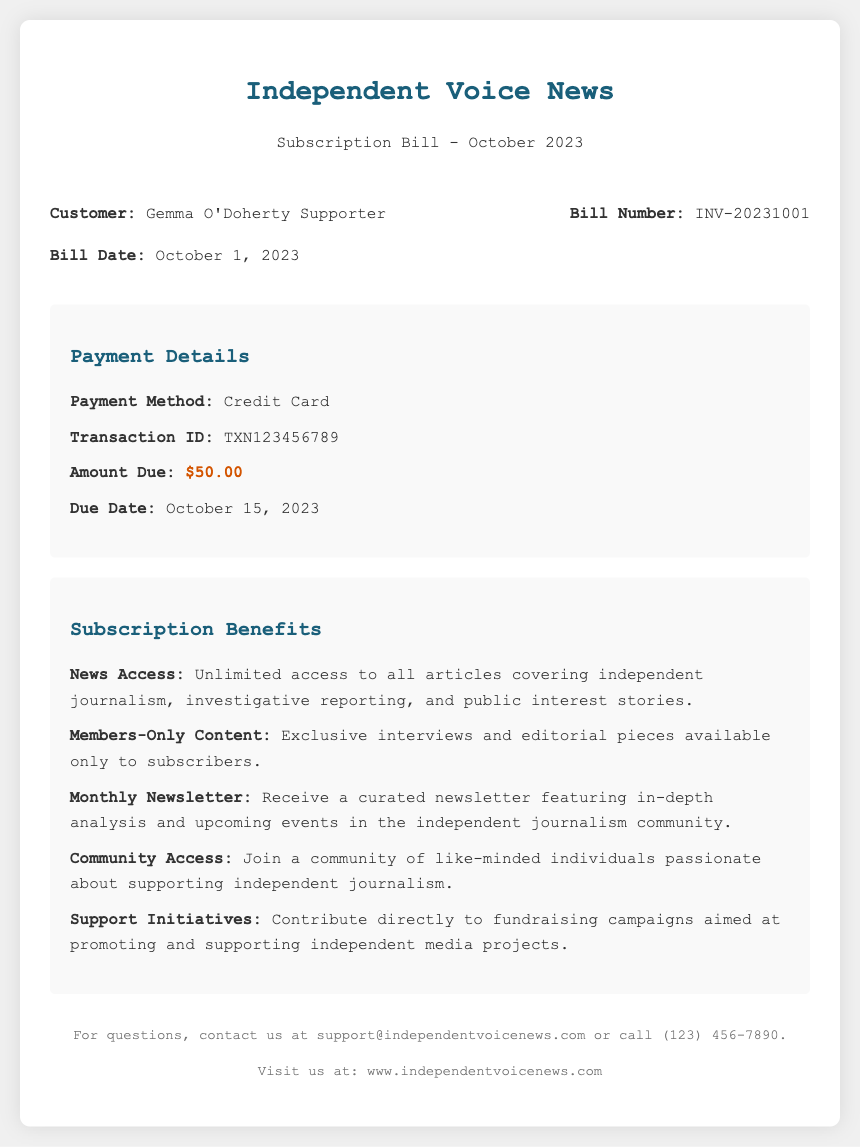What is the subscription amount due? The subscription amount due is explicitly stated in the payment details section.
Answer: $50.00 What is the due date for the payment? The due date for the payment is provided under the payment details.
Answer: October 15, 2023 What is the transaction ID for this payment? The transaction ID is included in the payment details section of the document.
Answer: TXN123456789 What is the bill number? The bill number can be found in the bill information area of the document.
Answer: INV-20231001 What type of payment method is used? The payment method is listed in the payment details section.
Answer: Credit Card What is one benefit of the subscription? Benefits of the subscription are detailed in the subscription benefits section.
Answer: Unlimited access to all articles How often will subscribers receive the newsletter? The frequency of the newsletter is described in the subscription benefits.
Answer: Monthly What is a community offering for subscribers? The benefits of community access are outlined in the subscription benefits section.
Answer: Join a community of like-minded individuals What date does this bill date indicate? The bill date indicates the date when the bill was issued.
Answer: October 1, 2023 